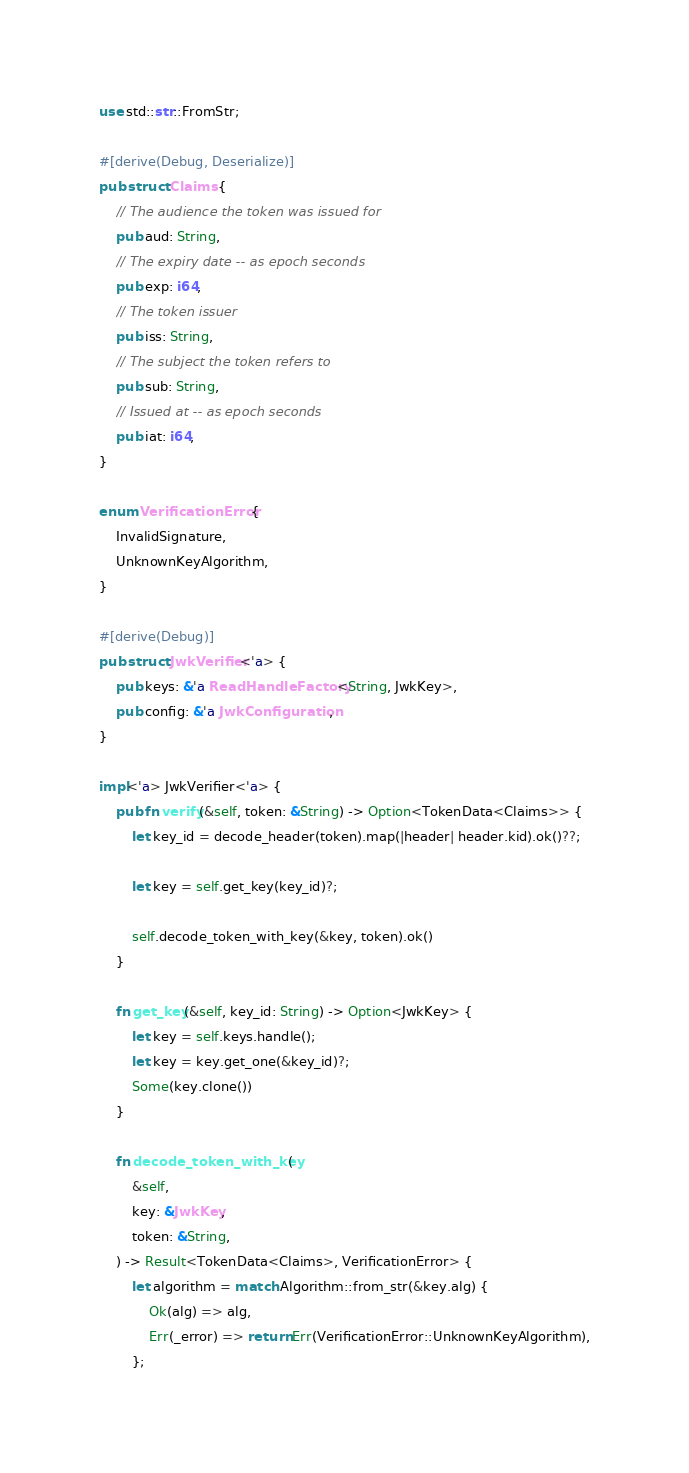Convert code to text. <code><loc_0><loc_0><loc_500><loc_500><_Rust_>use std::str::FromStr;

#[derive(Debug, Deserialize)]
pub struct Claims {
    // The audience the token was issued for
    pub aud: String,
    // The expiry date -- as epoch seconds
    pub exp: i64,
    // The token issuer
    pub iss: String,
    // The subject the token refers to
    pub sub: String,
    // Issued at -- as epoch seconds
    pub iat: i64,
}

enum VerificationError {
    InvalidSignature,
    UnknownKeyAlgorithm,
}

#[derive(Debug)]
pub struct JwkVerifier<'a> {
    pub keys: &'a ReadHandleFactory<String, JwkKey>,
    pub config: &'a JwkConfiguration,
}

impl<'a> JwkVerifier<'a> {
    pub fn verify(&self, token: &String) -> Option<TokenData<Claims>> {
        let key_id = decode_header(token).map(|header| header.kid).ok()??;

        let key = self.get_key(key_id)?;

        self.decode_token_with_key(&key, token).ok()
    }

    fn get_key(&self, key_id: String) -> Option<JwkKey> {
        let key = self.keys.handle();
        let key = key.get_one(&key_id)?;
        Some(key.clone())
    }

    fn decode_token_with_key(
        &self,
        key: &JwkKey,
        token: &String,
    ) -> Result<TokenData<Claims>, VerificationError> {
        let algorithm = match Algorithm::from_str(&key.alg) {
            Ok(alg) => alg,
            Err(_error) => return Err(VerificationError::UnknownKeyAlgorithm),
        };
</code> 